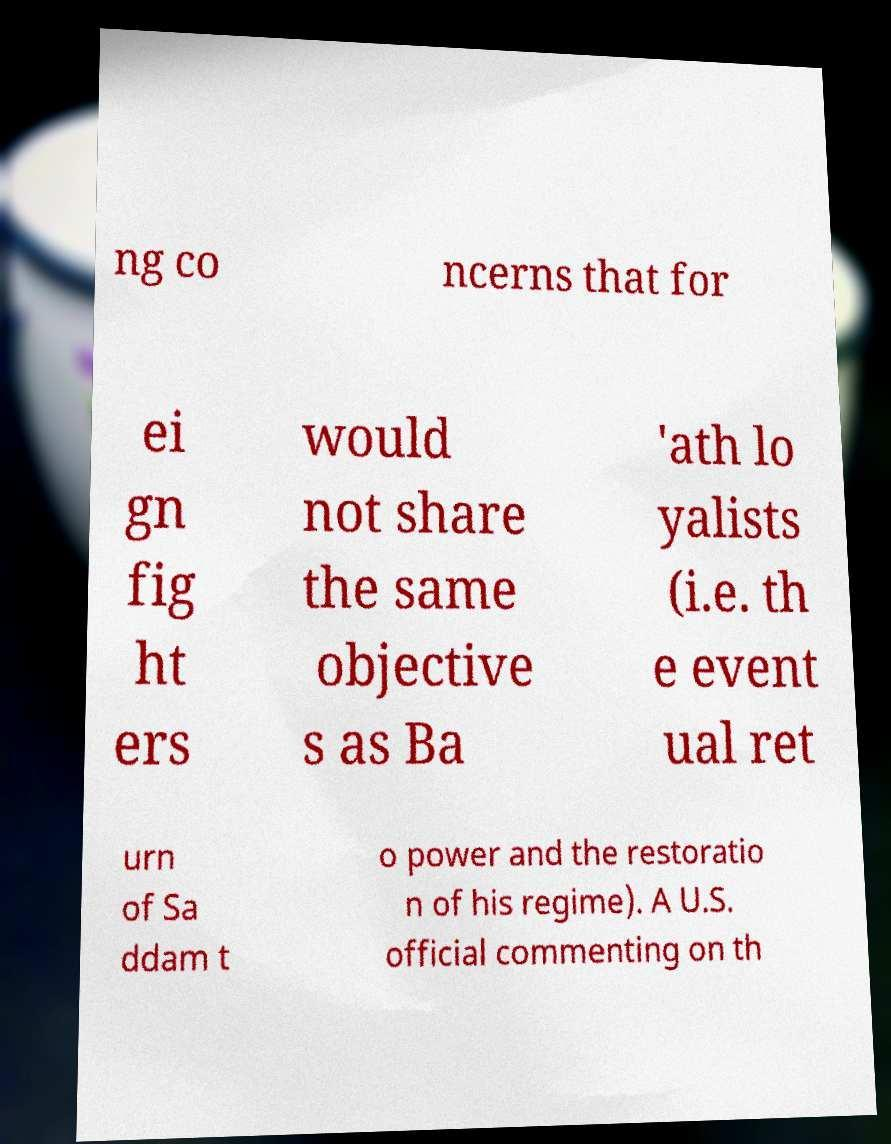Could you extract and type out the text from this image? ng co ncerns that for ei gn fig ht ers would not share the same objective s as Ba 'ath lo yalists (i.e. th e event ual ret urn of Sa ddam t o power and the restoratio n of his regime). A U.S. official commenting on th 